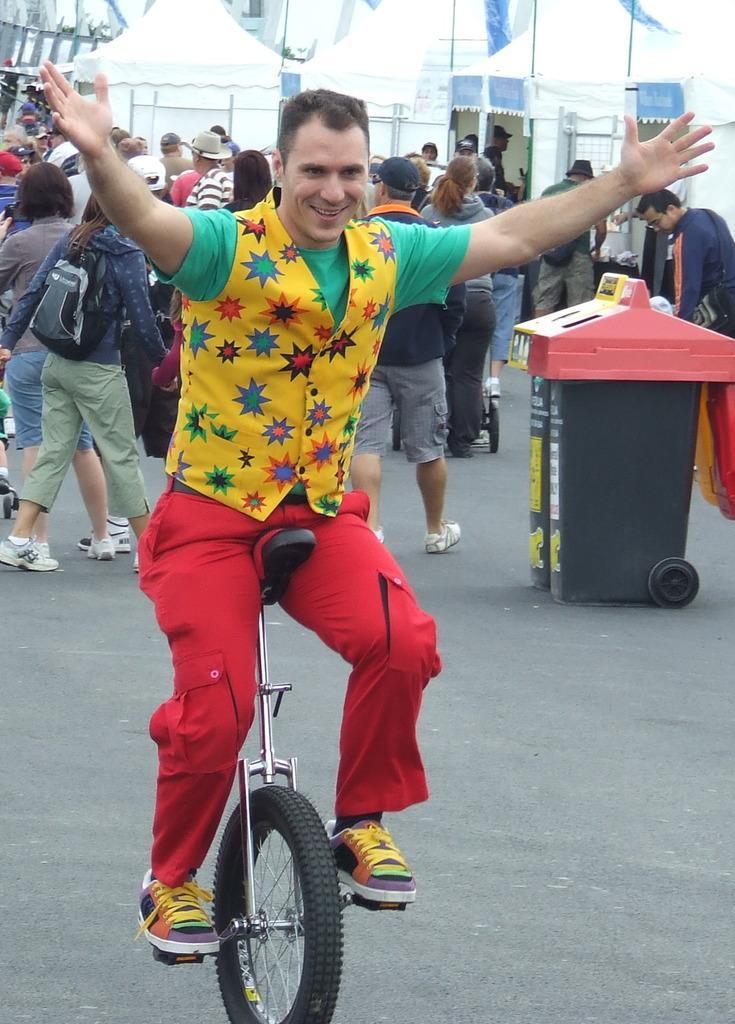Could you give a brief overview of what you see in this image? In this picture we can see man sitting on bicycle and smiling and at back of him we can see group of people some are standing and some are walking and in background we can see cloth, bins. 